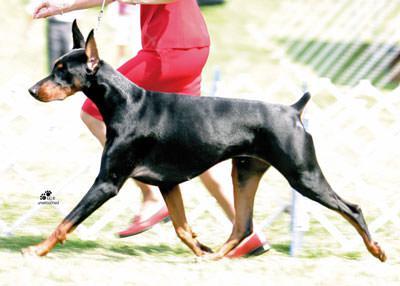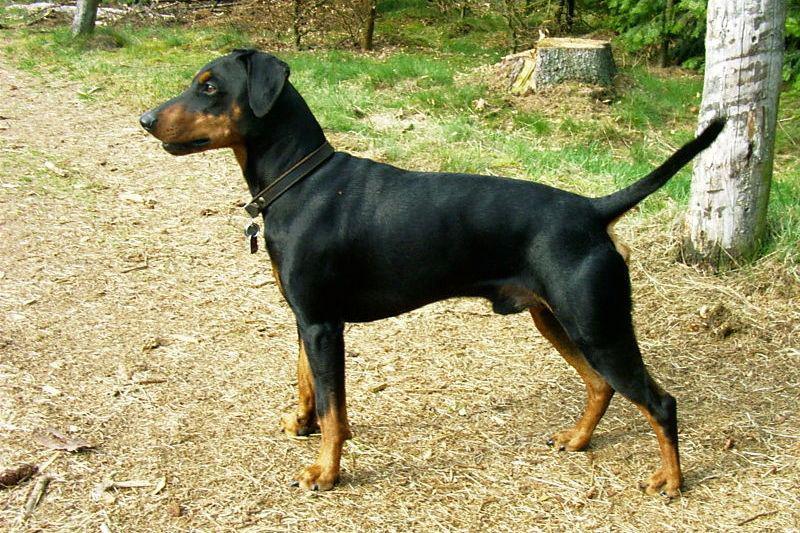The first image is the image on the left, the second image is the image on the right. Evaluate the accuracy of this statement regarding the images: "There are only two dogs.". Is it true? Answer yes or no. Yes. The first image is the image on the left, the second image is the image on the right. Evaluate the accuracy of this statement regarding the images: "There are exactly two dogs.". Is it true? Answer yes or no. Yes. 